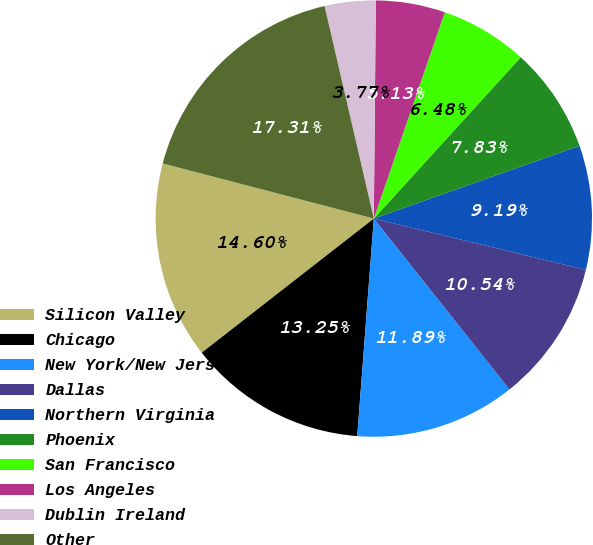<chart> <loc_0><loc_0><loc_500><loc_500><pie_chart><fcel>Silicon Valley<fcel>Chicago<fcel>New York/New Jersey<fcel>Dallas<fcel>Northern Virginia<fcel>Phoenix<fcel>San Francisco<fcel>Los Angeles<fcel>Dublin Ireland<fcel>Other<nl><fcel>14.6%<fcel>13.25%<fcel>11.89%<fcel>10.54%<fcel>9.19%<fcel>7.83%<fcel>6.48%<fcel>5.13%<fcel>3.77%<fcel>17.31%<nl></chart> 